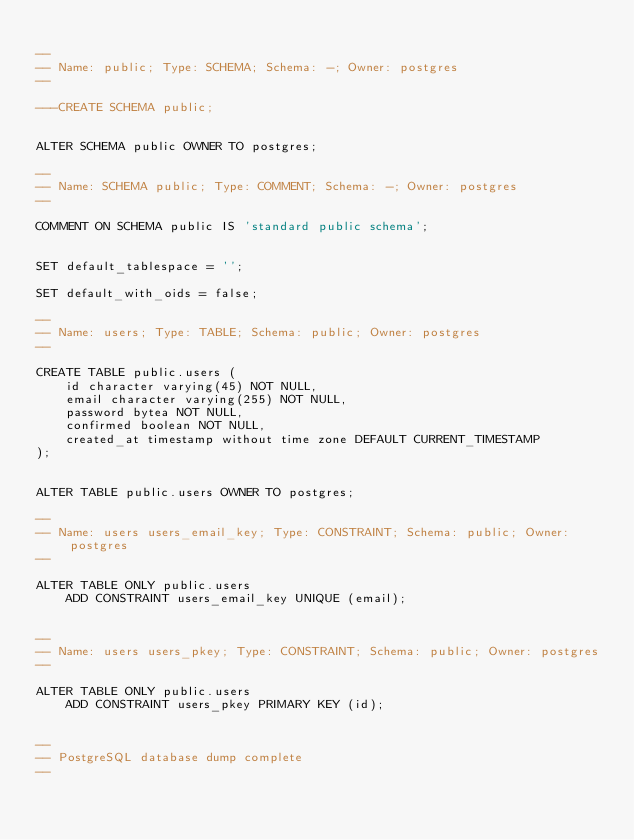Convert code to text. <code><loc_0><loc_0><loc_500><loc_500><_SQL_>
--
-- Name: public; Type: SCHEMA; Schema: -; Owner: postgres
--

---CREATE SCHEMA public;


ALTER SCHEMA public OWNER TO postgres;

--
-- Name: SCHEMA public; Type: COMMENT; Schema: -; Owner: postgres
--

COMMENT ON SCHEMA public IS 'standard public schema';


SET default_tablespace = '';

SET default_with_oids = false;

--
-- Name: users; Type: TABLE; Schema: public; Owner: postgres
--

CREATE TABLE public.users (
    id character varying(45) NOT NULL,
    email character varying(255) NOT NULL,
    password bytea NOT NULL,
    confirmed boolean NOT NULL,
    created_at timestamp without time zone DEFAULT CURRENT_TIMESTAMP
);


ALTER TABLE public.users OWNER TO postgres;

--
-- Name: users users_email_key; Type: CONSTRAINT; Schema: public; Owner: postgres
--

ALTER TABLE ONLY public.users
    ADD CONSTRAINT users_email_key UNIQUE (email);


--
-- Name: users users_pkey; Type: CONSTRAINT; Schema: public; Owner: postgres
--

ALTER TABLE ONLY public.users
    ADD CONSTRAINT users_pkey PRIMARY KEY (id);


--
-- PostgreSQL database dump complete
--

</code> 